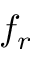<formula> <loc_0><loc_0><loc_500><loc_500>f _ { r }</formula> 